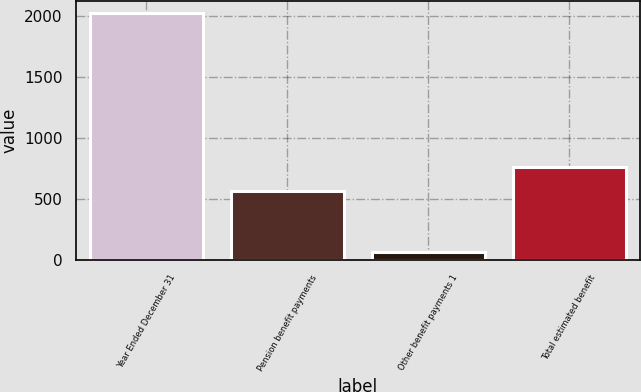Convert chart to OTSL. <chart><loc_0><loc_0><loc_500><loc_500><bar_chart><fcel>Year Ended December 31<fcel>Pension benefit payments<fcel>Other benefit payments 1<fcel>Total estimated benefit<nl><fcel>2020<fcel>570<fcel>67<fcel>765.3<nl></chart> 